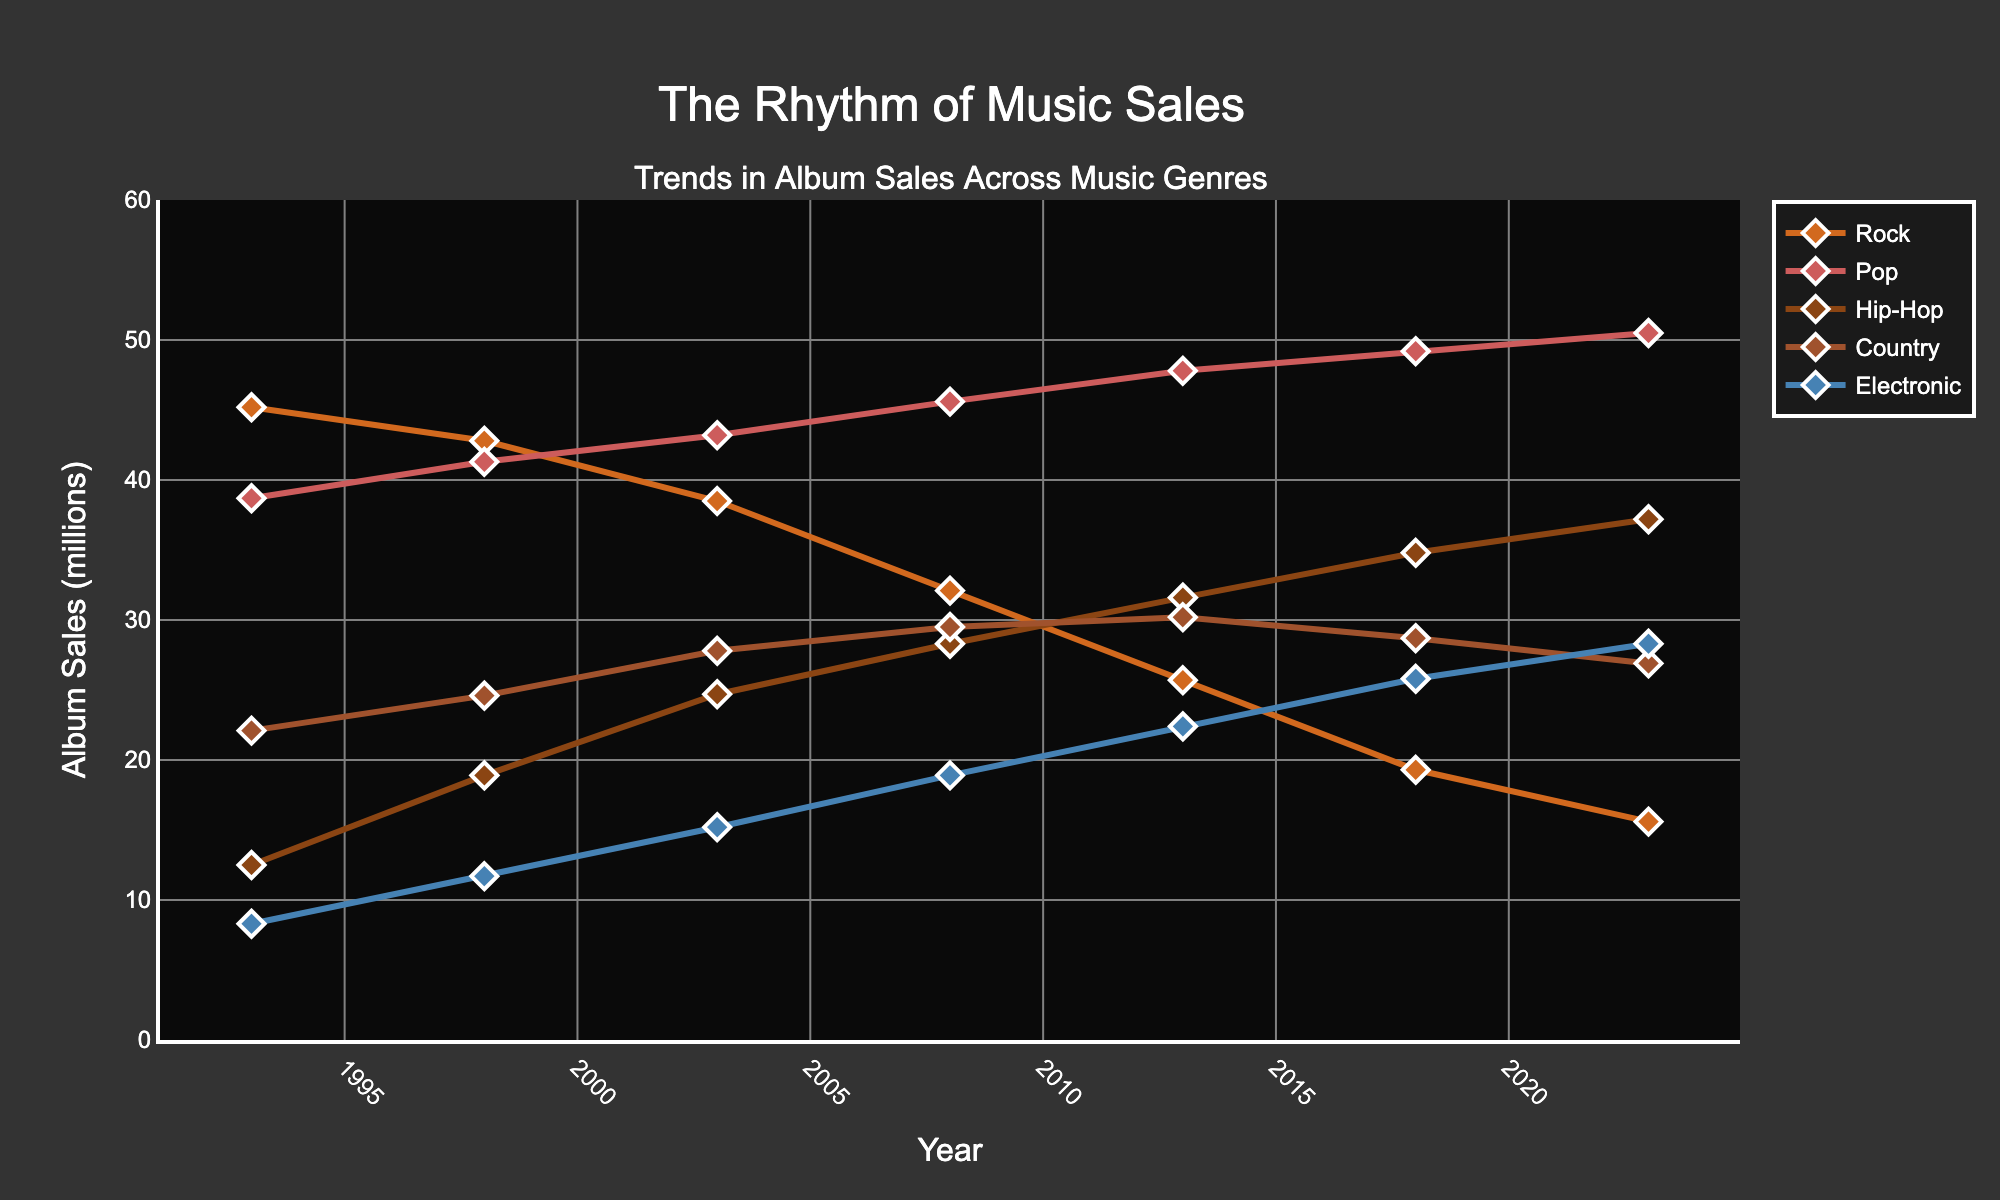What's the trend in Rock genre album sales over the past 30 years? First, observe the line representing Rock sales. It starts at 45.2 million in 1993 and gradually decreases to 15.6 million in 2023. This shows a declining trend in Rock album sales.
Answer: Declining Which genre had the highest album sales in 2023? Look at the end points of the lines for 2023. The Pop genre line is the highest, reaching 50.5 million.
Answer: Pop Between which two years did Hip-Hop see the most significant increase in album sales? Observe the slope of the Hip-Hop line. The steepest increase appears between 2003 (24.7 million) and 2008 (28.3 million), which results in an increase of 3.6 million.
Answer: 2003 and 2008 Which genre showed consistent growth across the 30 years? Look for a genre line that keeps rising. The Electronic genre line shows a consistent upward trend from 1993 (8.3 million) to 2023 (28.3 million).
Answer: Electronic Compare the sales of Country and Electronic genres in 2013. Which had higher sales, and by how much? In 2013, the sales for Country were 30.2 million and for Electronic were 22.4 million. Subtracting Electronic sales from Country sales gives the difference (30.2 - 22.4 = 7.8).
Answer: Country by 7.8 million Between 1993 and 2023, what was the overall change in album sales for the Pop genre? In 1993, Pop sales were 38.7 million, and in 2023 they were 50.5 million. The change is calculated by subtracting the earlier value from the later one (50.5 - 38.7 = 11.8).
Answer: Increase by 11.8 million Which genre had the highest increase in album sales between 1993 and 2023, and what was the amount? Calculate the increase for each genre over the period: Rock (45.2 - 15.6 = -29.6), Pop (50.5 - 38.7 = 11.8), Hip-Hop (37.2 - 12.5 = 24.7), Country (26.9 - 22.1 = 4.8), Electronic (28.3 - 8.3 = 20). Hip-Hop had the highest increase (24.7 million).
Answer: Hip-Hop by 24.7 million What was the average sales for the Hip-Hop genre over the whole period? Sum the Hip-Hop sales for all years given: (12.5 + 18.9 + 24.7 + 28.3 + 31.6 + 34.8 + 37.2 = 188), then divide by the number of data points (188 / 7 ≈ 26.9).
Answer: 26.9 million Which genres crossed paths in sales around 2013, indicating a significant shift? Near 2013, observe lines intersecting points. The Country and Electronic genre lines cross each other around this year.
Answer: Country and Electronic In 1998, how did Rock and Pop album sales compare, and by what percentage was one higher than the other? For 1998, Rock sales were 42.8 million and Pop sales were 41.3 million. The difference is 42.8 - 41.3 = 1.5 million. To find the percentage: (1.5 / 41.3) * 100 ≈ 3.63%.
Answer: Rock by approximately 3.63% 